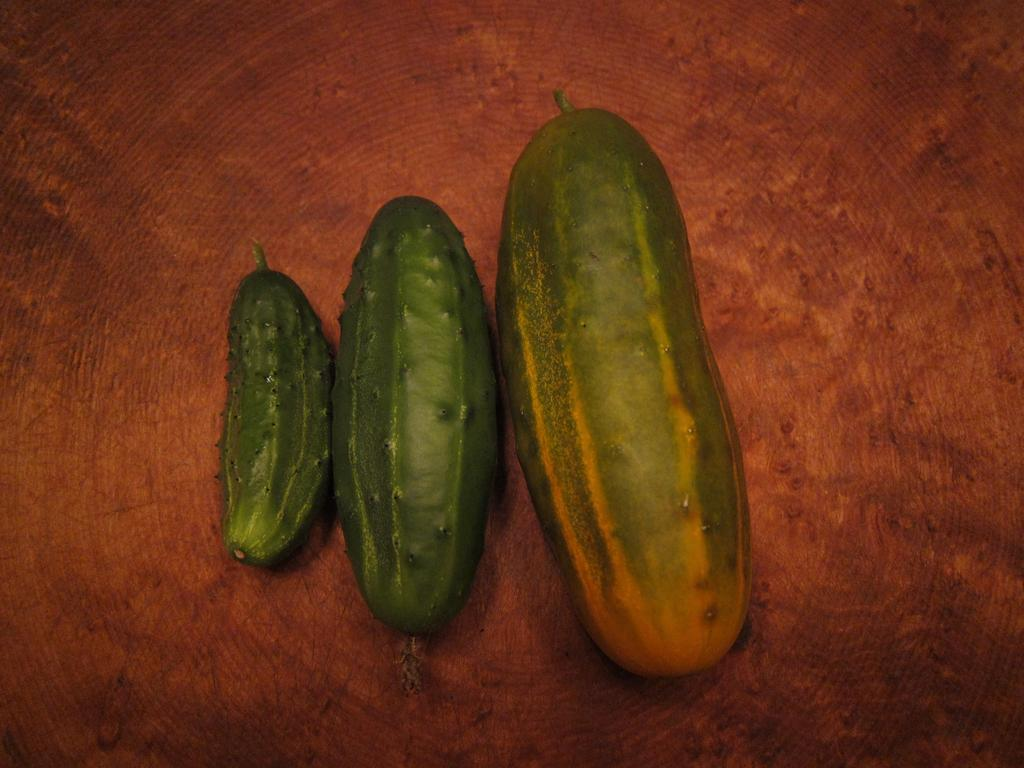How many cucumbers are visible in the image? There are three cucumbers in the image. Can you describe the cucumbers in terms of their sizes? The cucumbers are of different sizes. Where are the cucumbers located in the image? The cucumbers are on a platform. What type of shoes are the cucumbers wearing in the image? There are no shoes present in the image, as the main subjects are cucumbers. Can you tell me how many basketballs are visible in the image? There are no basketballs present in the image; the main subjects are cucumbers. 